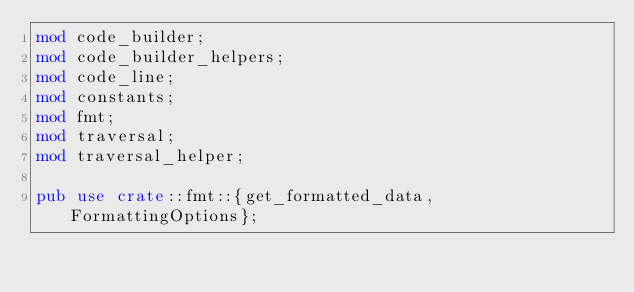Convert code to text. <code><loc_0><loc_0><loc_500><loc_500><_Rust_>mod code_builder;
mod code_builder_helpers;
mod code_line;
mod constants;
mod fmt;
mod traversal;
mod traversal_helper;

pub use crate::fmt::{get_formatted_data, FormattingOptions};
</code> 